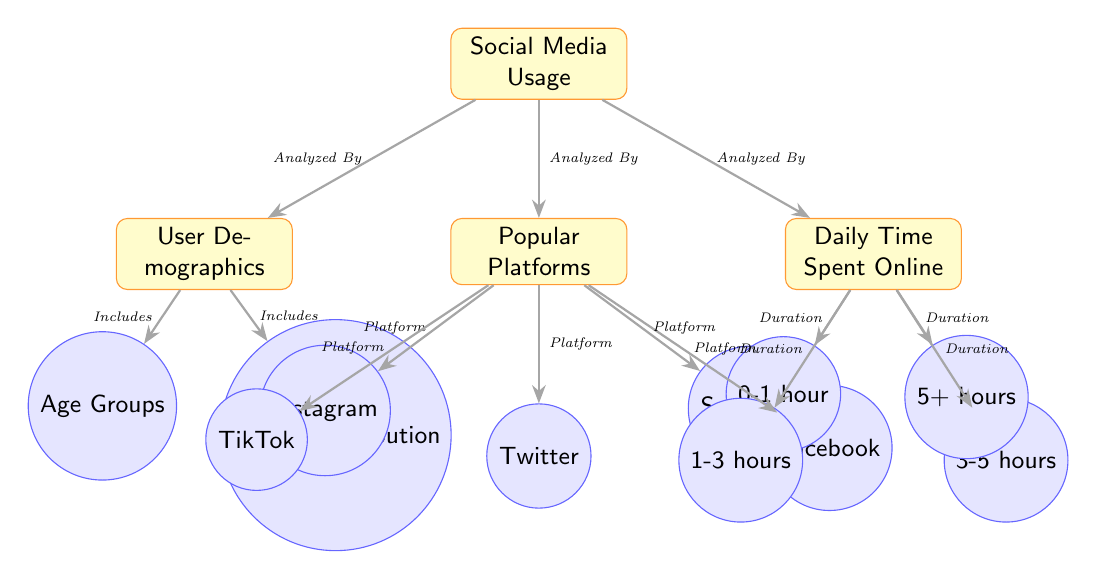What are the main categories of social media usage analyzed in the diagram? The diagram contains three main categories: User Demographics, Popular Platforms, and Daily Time Spent Online. These categories provide a structured view of how social media is utilized among college students.
Answer: User Demographics, Popular Platforms, Daily Time Spent Online How many popular social media platforms are included in the analysis? The platforms listed in the diagram are Instagram, TikTok, Twitter, Facebook, and Snapchat. Counting these, we have a total of five platforms being analyzed.
Answer: 5 Which demographic aspect is included along with age groups? In addition to age groups, the diagram also includes gender distribution as a demographic aspect, emphasizing the analysis of user demographics among college students.
Answer: Gender Distribution What is the duration range for the daily time spent on social media that is listed? The diagram presents four duration categories: 0-1 hour, 1-3 hours, 3-5 hours, and 5+ hours. These categories capture the spectrum of time students spend online.
Answer: 0-1 hour, 1-3 hours, 3-5 hours, 5+ hours Which platform is positioned furthest to the left in the diagram? Among the popular platforms listed, Instagram is the one positioned furthest to the left, indicating its relevance or priority in the context of social media usage among college students.
Answer: Instagram What does the connection marked "Analyzed By" indicate about the relationships in the diagram? The connections labeled "Analyzed By" indicate that the categories of demographics, platforms, and time are all examined in relation to the overall theme of social media usage among college students, highlighting their interdependence.
Answer: Examined in relation to usage How many nodes represent time spent online, and what are their categories? There are four nodes representing time spent online: 0-1 hour, 1-3 hours, 3-5 hours, and 5+ hours. This categorization allows for a detailed understanding of the varying daily usage durations among students.
Answer: 4: 0-1 hour, 1-3 hours, 3-5 hours, 5+ hours What is the relationship between demographics and the two specific aspects mentioned? The diagram shows that demographics include both age groups and gender distribution, illustrating how these two aspects contribute to the overall analysis of social media usage among college students.
Answer: Includes age groups and gender distribution 